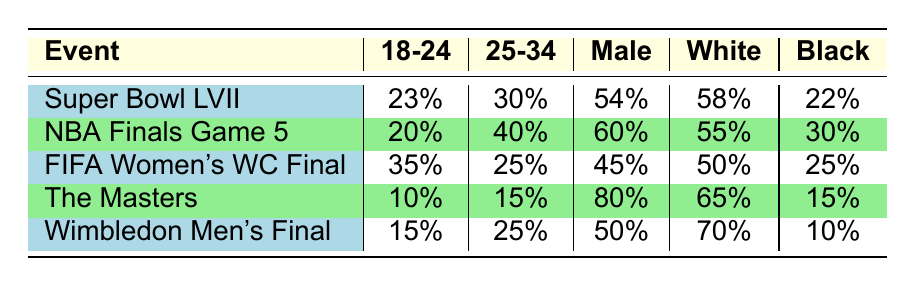What is the percentage of the audience aged 25-34 for the NBA Finals Game 5? By examining the table, we can directly see that the percentage of the audience aged 25-34 for this event is provided as 40%.
Answer: 40% Which sporting event has the highest percentage of male audience? Looking at the gender distribution for each event listed in the table, The Masters has the highest percentage of male audience at 80%.
Answer: 80% What is the ethnic distribution percentage of Black audience at the FIFA Women's World Cup Final? The table shows that the ethnic distribution percentage for Black audience at the FIFA Women's World Cup Final is 25%.
Answer: 25% What is the average percentage of the audience aged 55+ across all listed events? Adding the percentages of audiences aged 55+ across all events: 12% (Super Bowl) + 5% (NBA Finals) + 10% (FIFA Women's WC Final) + 25% (The Masters) + 10% (Wimbledon) = 62%. There are 5 events, thus the average is 62% / 5 = 12.4%.
Answer: 12.4% Is the percentage of female audience at Wimbledon Men's Final equal to that at The Masters? The table indicates that the female audience percentage at Wimbledon Men's Final is 50%, while at The Masters it is 20%. Since these values are not equal, the answer is no.
Answer: No Which event has the lowest percentage of audience aged 18-24? By reviewing the age distribution in the table, The Masters has the lowest percentage of audience aged 18-24 at 10%.
Answer: 10% How much higher is the percentage of White audience at Wimbledon Men's Final compared to the FIFA Women’s World Cup Final? The percentage of White audience at Wimbledon Men's Final is 70%, while at the FIFA Women's World Cup Final it is 50%. Thus, the difference is 70% - 50% = 20%.
Answer: 20% What percentage of the audience at the Super Bowl LVII was aged 35-44? The table shows that the percentage of the audience aged 35-44 at the Super Bowl LVII is 20%.
Answer: 20% What percentage of the total audience for the NBA Finals Game 5 is female? The gender distribution indicates that the percentage of female audience for the NBA Finals Game 5 is 40%.
Answer: 40% Which event has the highest percentage of the audience aged 18-24? The table reveals that the FIFA Women’s World Cup Final has the highest percentage of the audience aged 18-24 at 35%.
Answer: 35% 